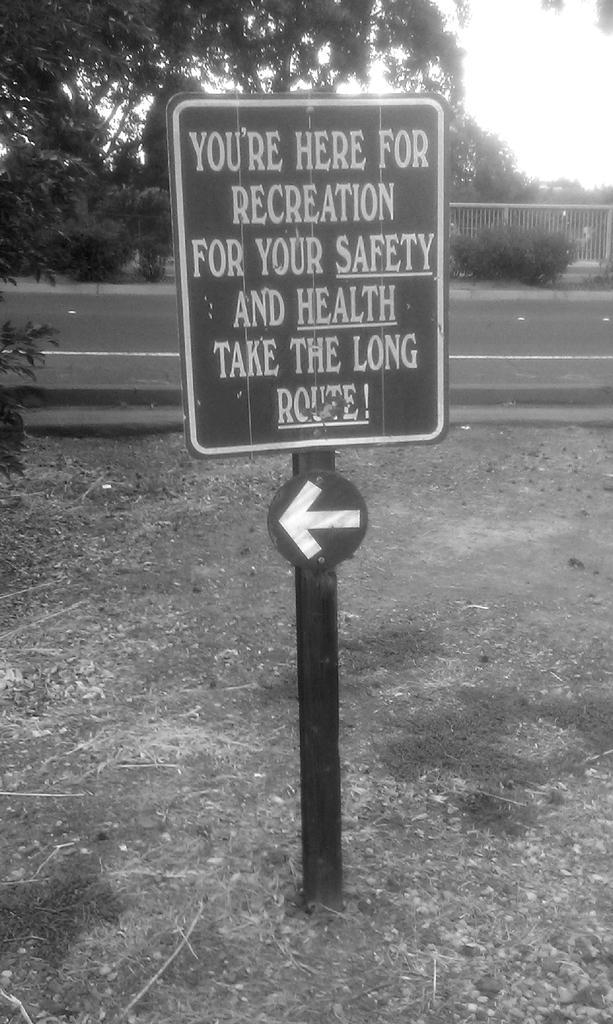Describe this image in one or two sentences. In this image I can see the board attached to the pole, background I can see few trees, the railing and I can also see the sky and the image is in black and white. 